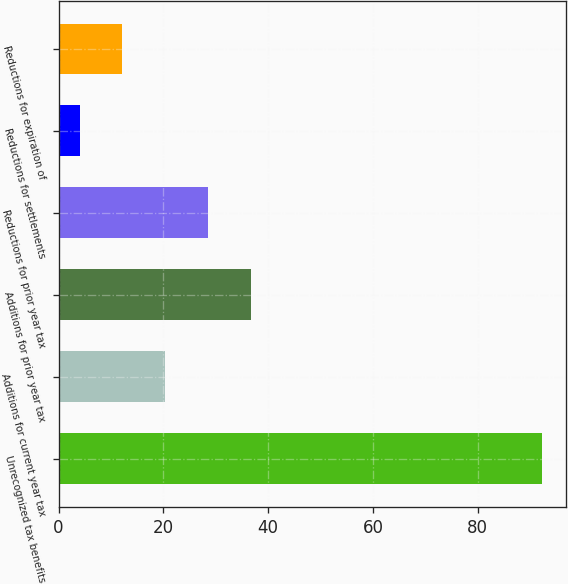Convert chart to OTSL. <chart><loc_0><loc_0><loc_500><loc_500><bar_chart><fcel>Unrecognized tax benefits<fcel>Additions for current year tax<fcel>Additions for prior year tax<fcel>Reductions for prior year tax<fcel>Reductions for settlements<fcel>Reductions for expiration of<nl><fcel>92.2<fcel>20.4<fcel>36.8<fcel>28.6<fcel>4<fcel>12.2<nl></chart> 